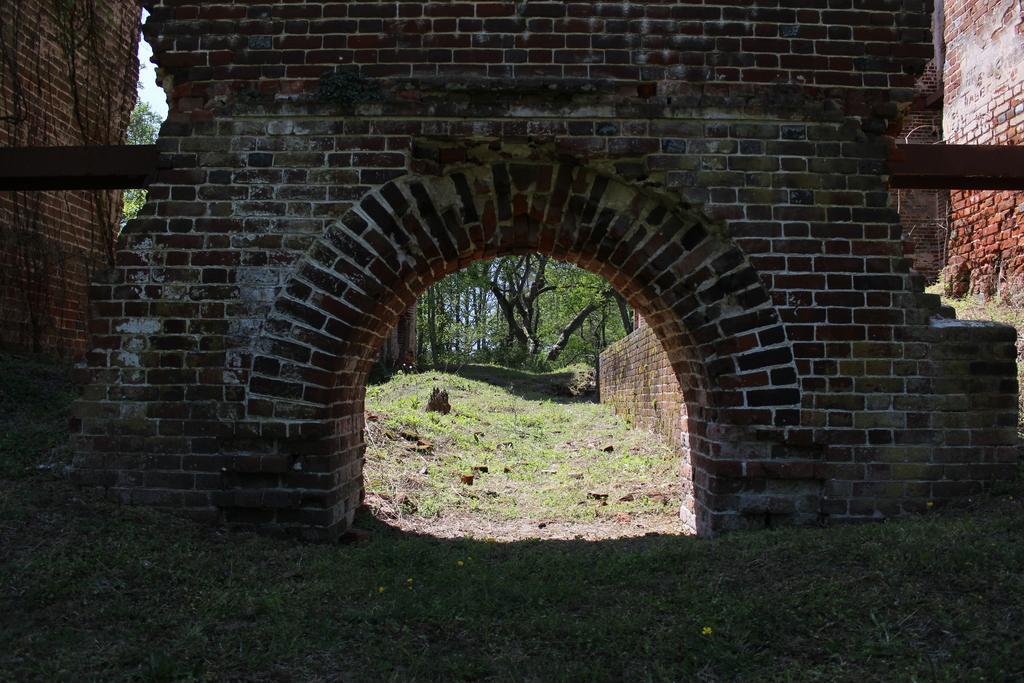Can you describe this image briefly? In this image I can see brick walls, grass and trees. 